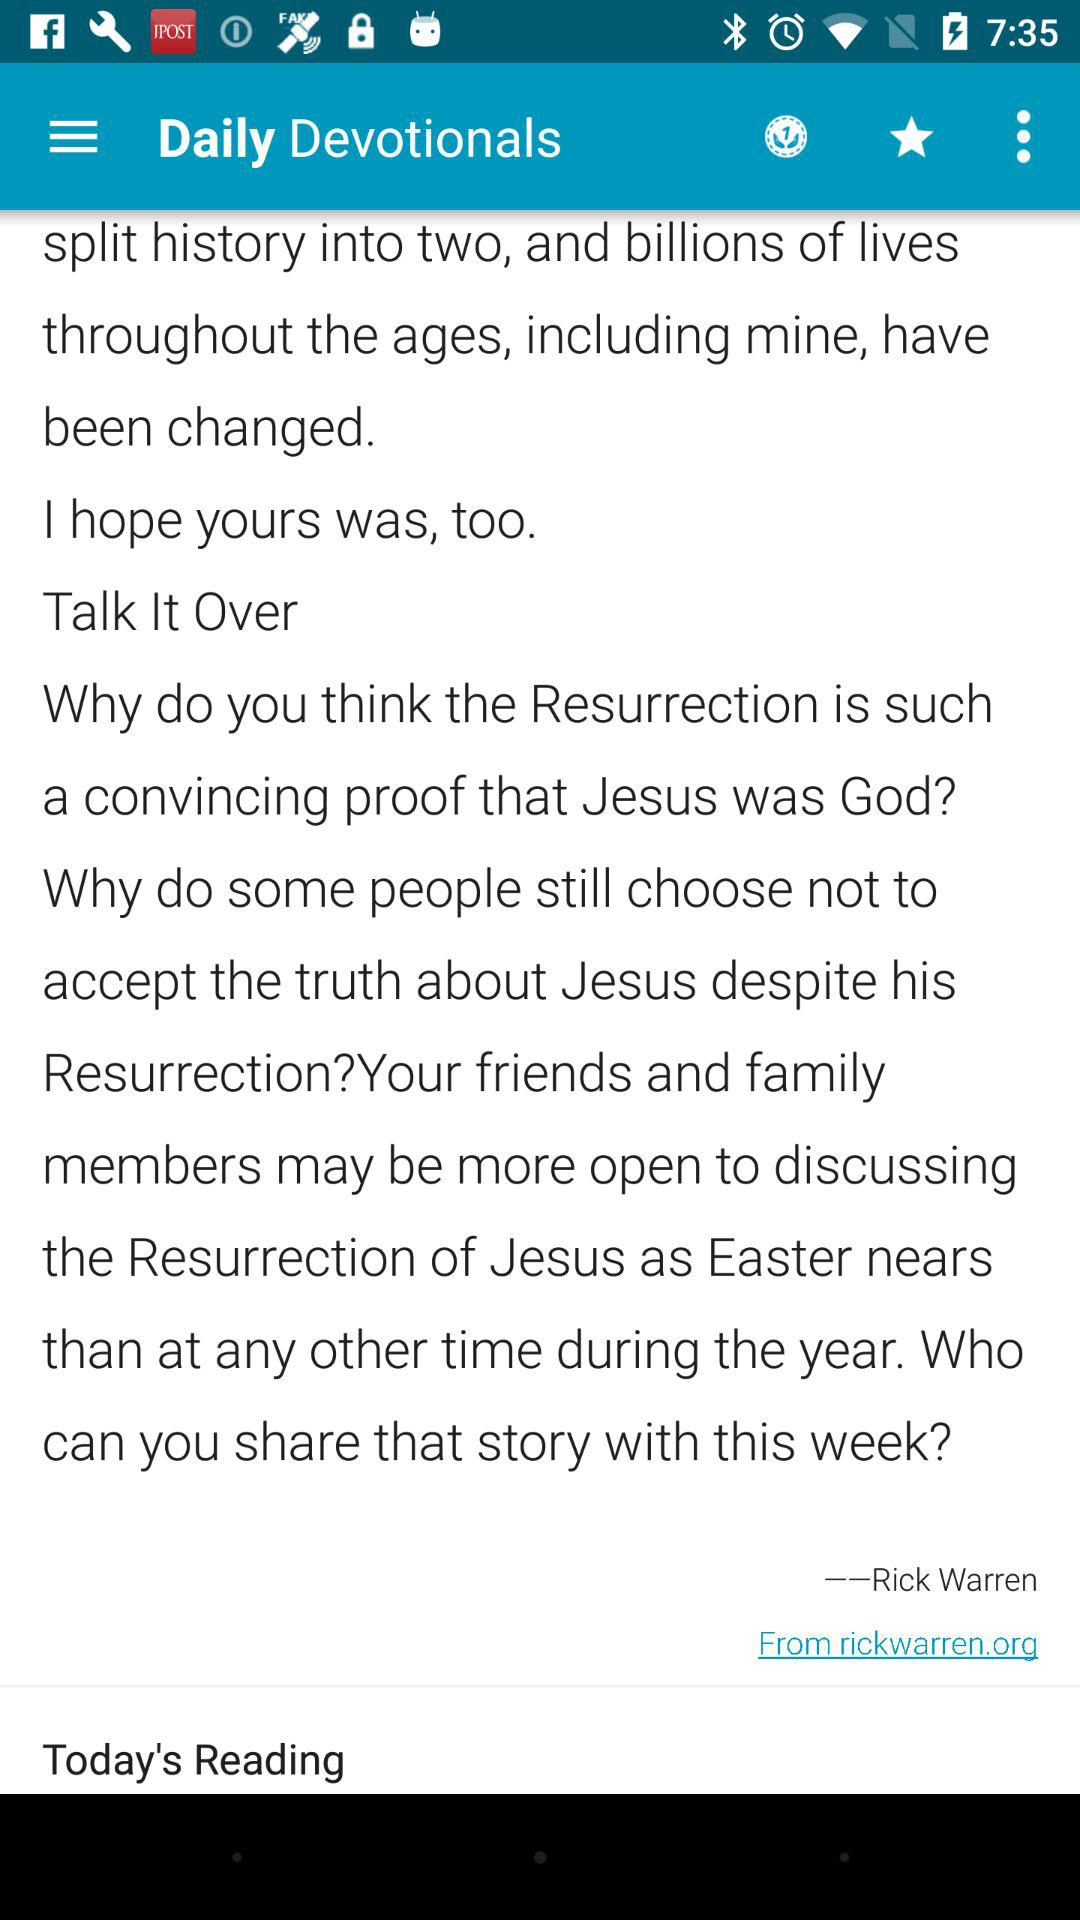How many daily devotionals are there for today?
When the provided information is insufficient, respond with <no answer>. <no answer> 